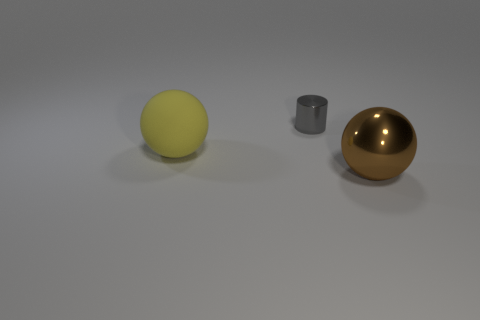Are there any other things that are made of the same material as the big yellow thing?
Provide a succinct answer. No. Do the big thing that is behind the metallic ball and the tiny thing have the same material?
Provide a succinct answer. No. What number of metallic things are both behind the large yellow rubber ball and in front of the cylinder?
Make the answer very short. 0. How many other gray objects have the same material as the small gray object?
Ensure brevity in your answer.  0. What color is the cylinder that is made of the same material as the brown ball?
Keep it short and to the point. Gray. Is the number of tiny cylinders less than the number of tiny red cylinders?
Give a very brief answer. No. There is a big thing on the left side of the shiny thing that is in front of the sphere on the left side of the small gray thing; what is it made of?
Provide a succinct answer. Rubber. What is the small gray cylinder made of?
Give a very brief answer. Metal. Is the number of tiny gray things greater than the number of large spheres?
Make the answer very short. No. There is another large object that is the same shape as the yellow rubber thing; what is its color?
Offer a very short reply. Brown. 